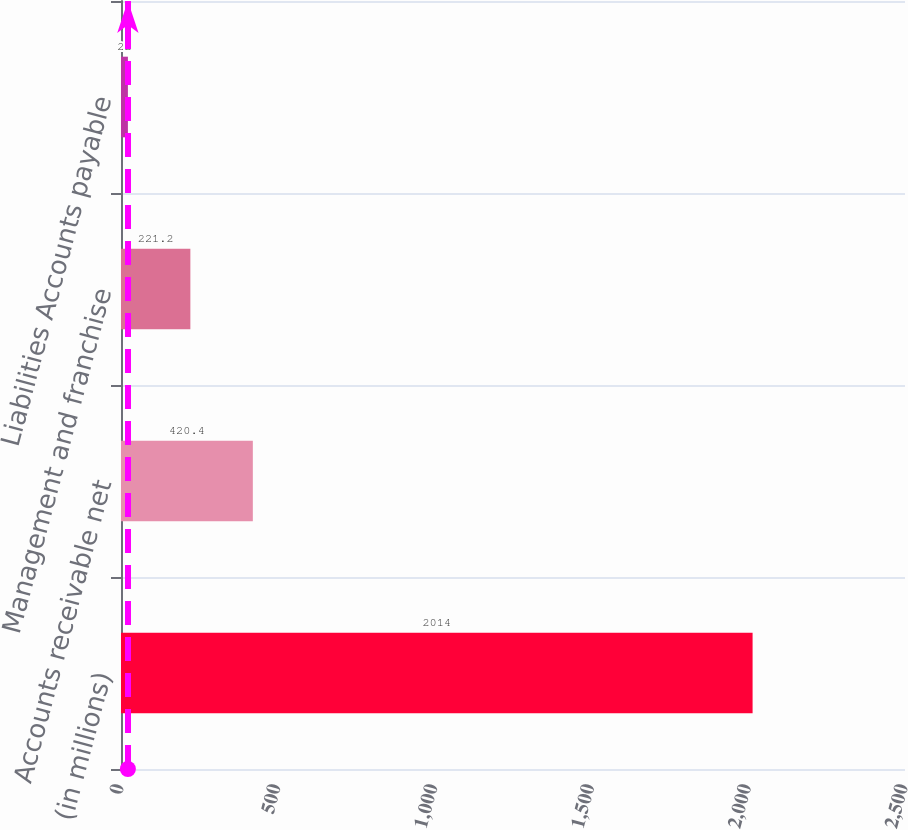<chart> <loc_0><loc_0><loc_500><loc_500><bar_chart><fcel>(in millions)<fcel>Accounts receivable net<fcel>Management and franchise<fcel>Liabilities Accounts payable<nl><fcel>2014<fcel>420.4<fcel>221.2<fcel>22<nl></chart> 